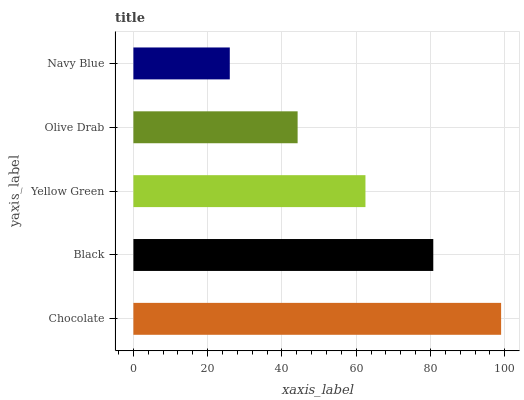Is Navy Blue the minimum?
Answer yes or no. Yes. Is Chocolate the maximum?
Answer yes or no. Yes. Is Black the minimum?
Answer yes or no. No. Is Black the maximum?
Answer yes or no. No. Is Chocolate greater than Black?
Answer yes or no. Yes. Is Black less than Chocolate?
Answer yes or no. Yes. Is Black greater than Chocolate?
Answer yes or no. No. Is Chocolate less than Black?
Answer yes or no. No. Is Yellow Green the high median?
Answer yes or no. Yes. Is Yellow Green the low median?
Answer yes or no. Yes. Is Black the high median?
Answer yes or no. No. Is Black the low median?
Answer yes or no. No. 